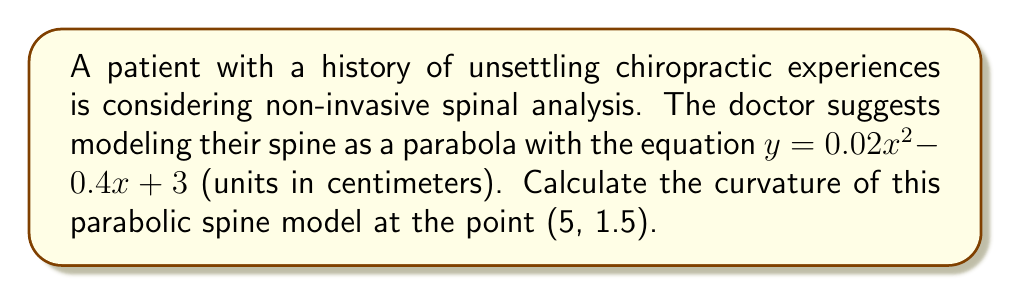Show me your answer to this math problem. To calculate the curvature of the parabolic spine model, we'll follow these steps:

1) The general formula for curvature $K$ of a curve $y = f(x)$ at a point $(x, y)$ is:

   $$K = \frac{|f''(x)|}{(1 + [f'(x)]^2)^{3/2}}$$

2) First, let's find $f'(x)$ and $f''(x)$:
   
   $f(x) = 0.02x^2 - 0.4x + 3$
   $f'(x) = 0.04x - 0.4$
   $f''(x) = 0.04$

3) Now, let's evaluate $f'(x)$ at $x = 5$:
   
   $f'(5) = 0.04(5) - 0.4 = -0.2$

4) We can now substitute these values into the curvature formula:

   $$K = \frac{|0.04|}{(1 + [-0.2]^2)^{3/2}}$$

5) Simplify:
   
   $$K = \frac{0.04}{(1 + 0.04)^{3/2}} = \frac{0.04}{1.04^{3/2}}$$

6) Calculate the final value:
   
   $$K \approx 0.0385 \text{ cm}^{-1}$$

This curvature value represents the rate at which the spine's curve is changing at the point (5, 1.5). A lower value indicates a gentler curve, which might be reassuring for a patient with concerns about spinal manipulation.
Answer: $K \approx 0.0385 \text{ cm}^{-1}$ 